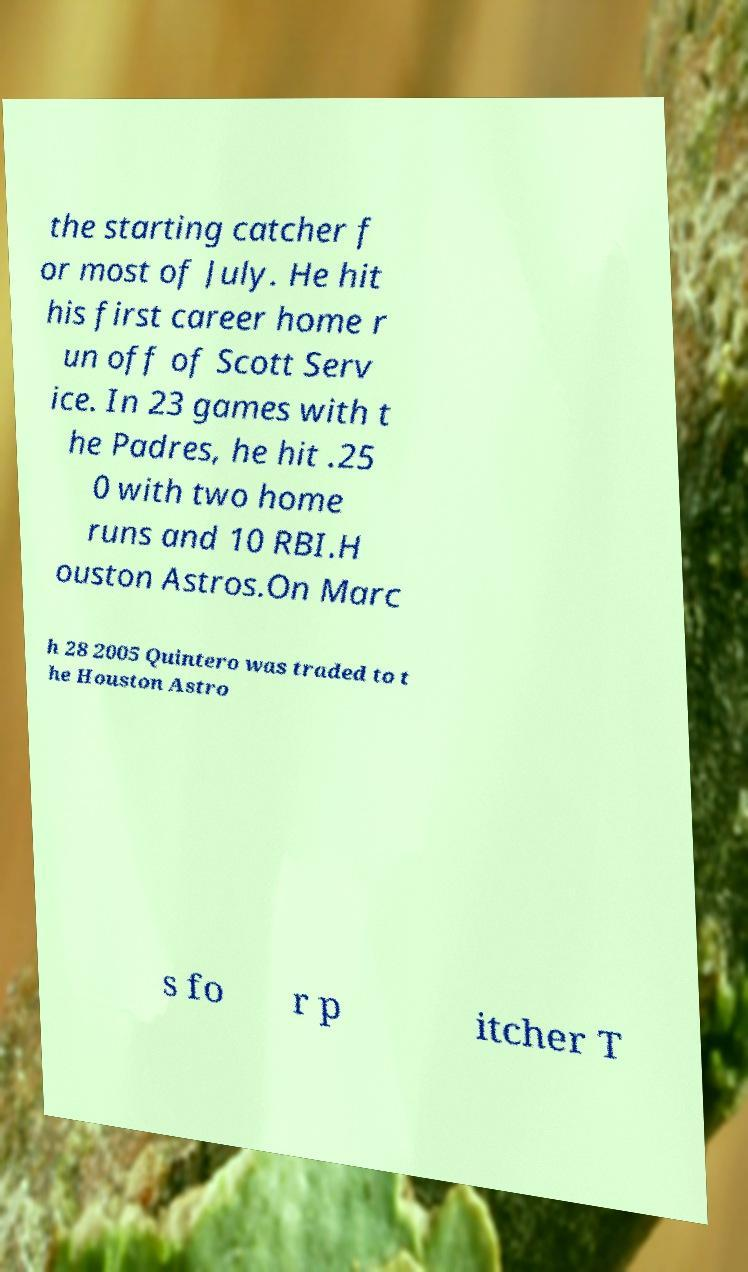There's text embedded in this image that I need extracted. Can you transcribe it verbatim? the starting catcher f or most of July. He hit his first career home r un off of Scott Serv ice. In 23 games with t he Padres, he hit .25 0 with two home runs and 10 RBI.H ouston Astros.On Marc h 28 2005 Quintero was traded to t he Houston Astro s fo r p itcher T 